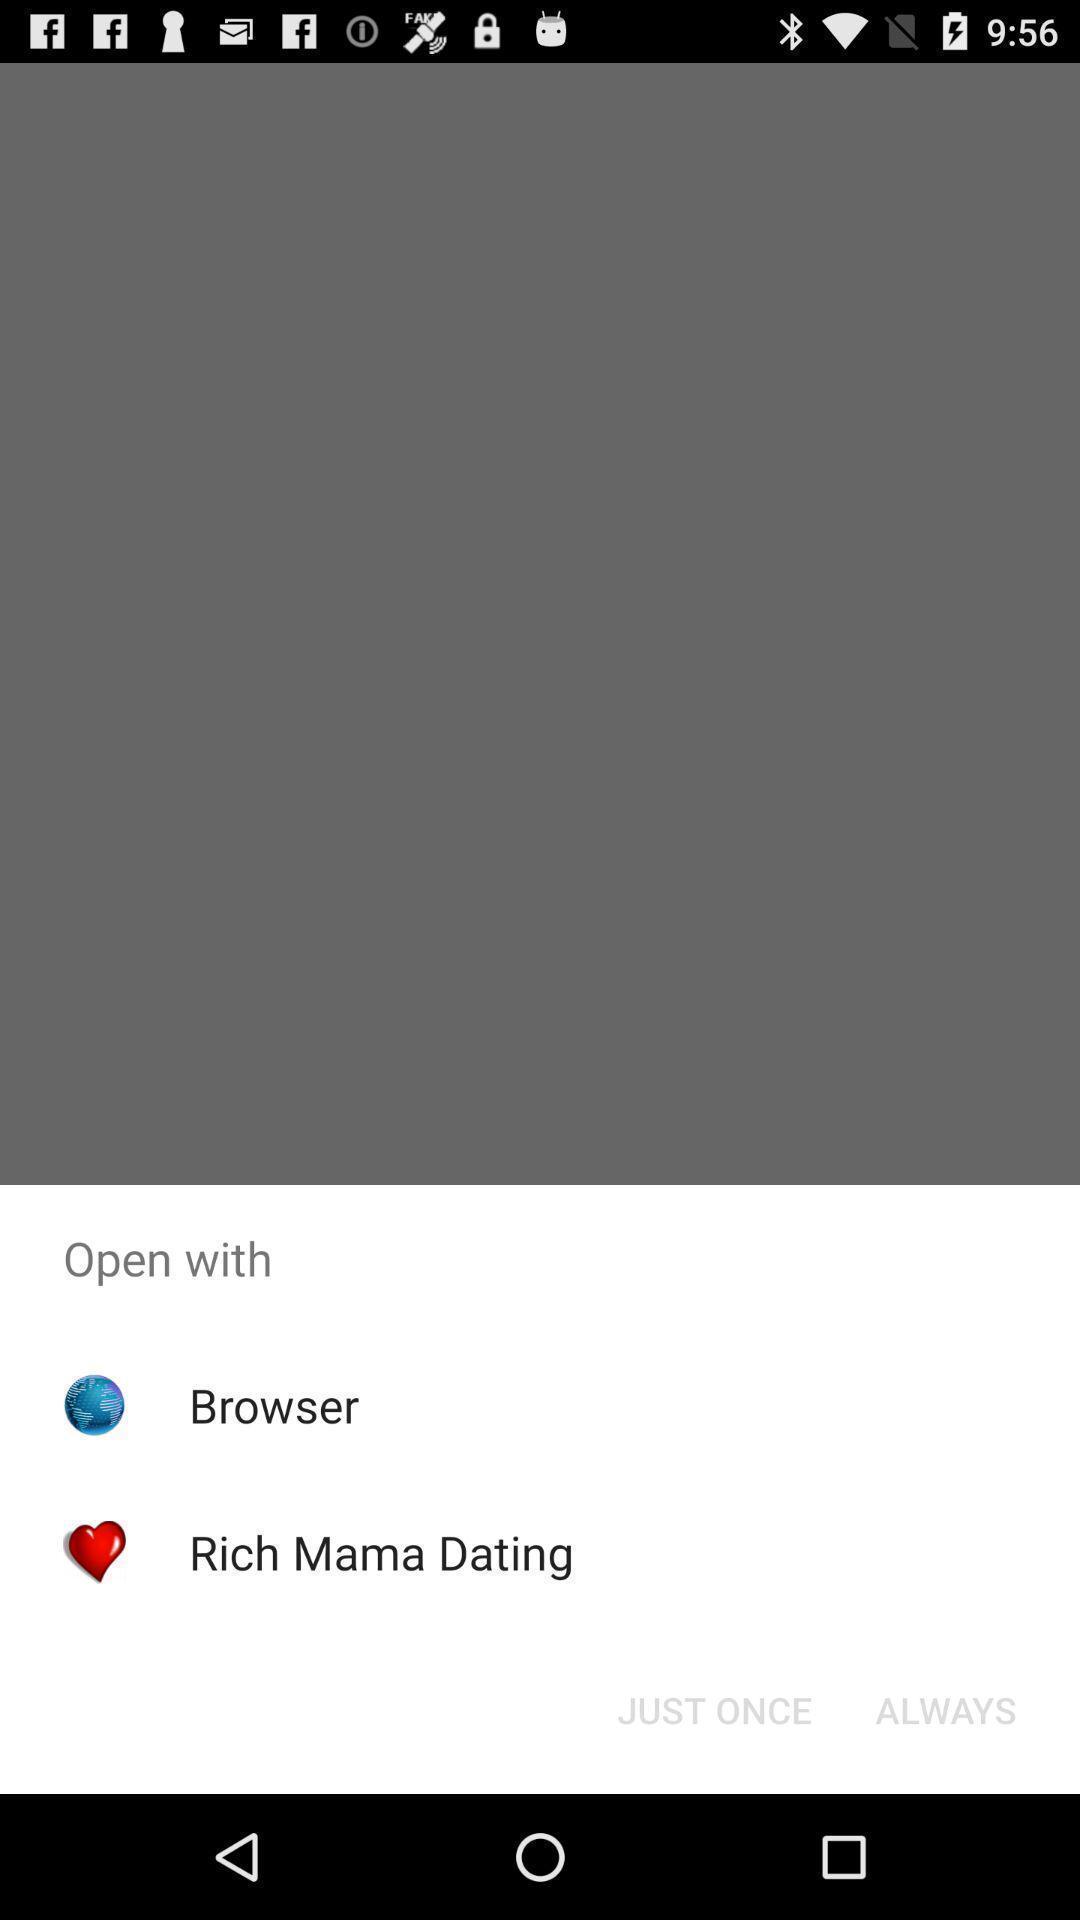Describe the visual elements of this screenshot. Pop up notification to open the app. 